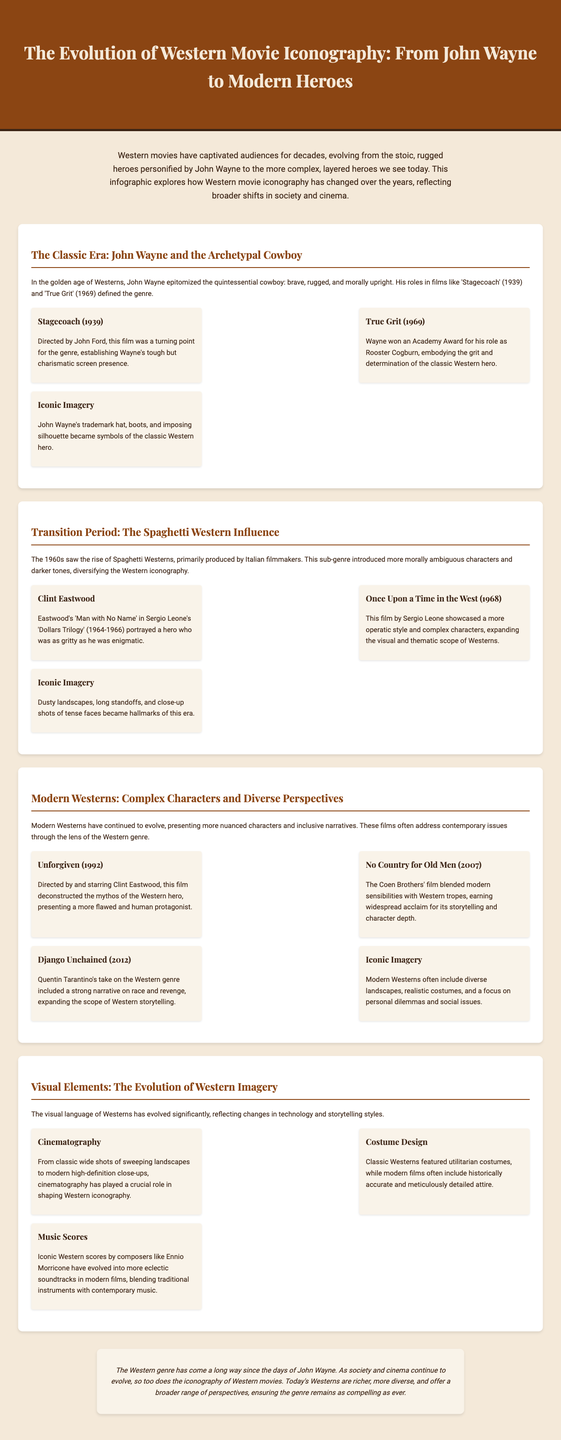What film established John Wayne's tough screen presence? The document mentions 'Stagecoach' as a turning point for the genre, establishing Wayne's tough but charismatic screen presence.
Answer: Stagecoach Which actor won an Academy Award for his role in 'True Grit'? The document states that John Wayne won an Academy Award for his role as Rooster Cogburn in 'True Grit'.
Answer: John Wayne What year was 'Once Upon a Time in the West' released? The document mentions that 'Once Upon a Time in the West' was released in 1968.
Answer: 1968 What character did Clint Eastwood portray in the 'Dollars Trilogy'? The document refers to Clint Eastwood's character as 'Man with No Name' in the 'Dollars Trilogy'.
Answer: Man with No Name Which film deconstructed the mythos of the Western hero? The document specifies that 'Unforgiven' presents a more flawed and human protagonist, thus deconstructing the mythos of the Western hero.
Answer: Unforgiven What type of landscapes became hallmarks of the Spaghetti Western era? The document states that dusty landscapes, long standoffs, and close-up shots of tense faces became hallmarks of the Spaghetti Western era.
Answer: Dusty landscapes What significant change does modern Westerns embrace compared to classic Westerns? The document mentions that modern Westerns present more nuanced characters and inclusive narratives compared to classical Westerns.
Answer: Nuanced characters What role does cinematography play in the evolution of Western imagery? The document highlights the significant role of cinematography in shaping Western iconography, from classic wide shots to modern high-definition close-ups.
Answer: Shaping Western iconography What does the conclusion suggest about the future of Western movies? The conclusion states that today's Westerns are richer, more diverse, and offer a broader range of perspectives, suggesting its ongoing appeal.
Answer: Ongoing appeal 